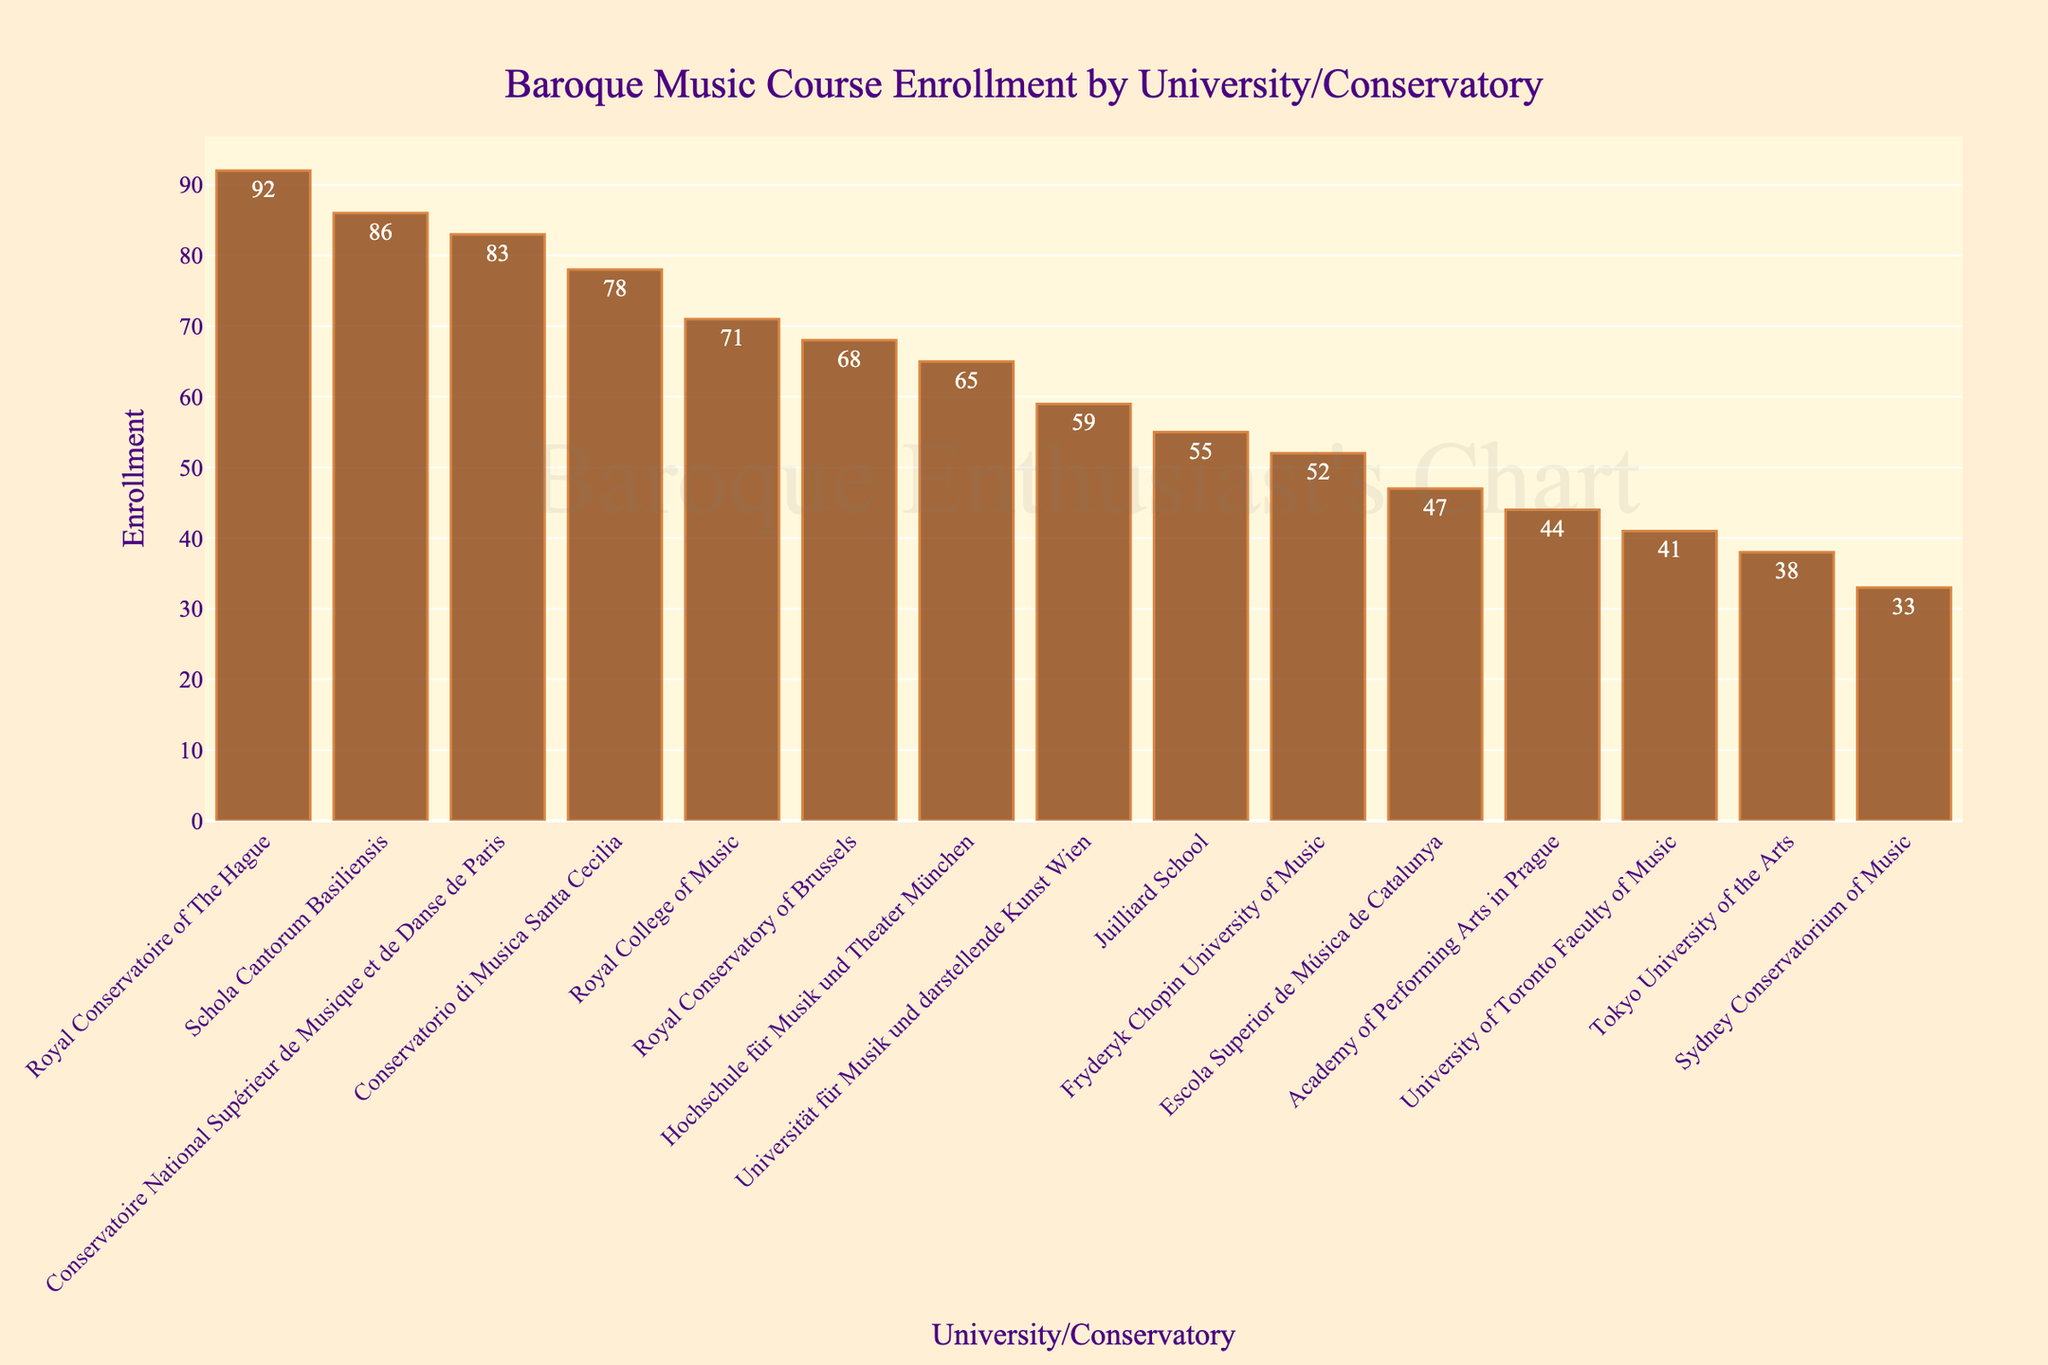Which university/conservatory has the highest enrollment in Baroque Music courses? Look for the tallest bar in the bar chart, which represents the university/conservatory with the highest enrollment. The Royal Conservatoire of The Hague has the highest enrollment.
Answer: Royal Conservatoire of The Hague Which country appears most frequently in the top 5 universities/conservatories for Baroque Music course enrollment? Identify the top 5 universities/conservatories based on bar height, then check the country associated with each. Netherland, France, Switzerland, Italy, and United Kingdom are the top 5, so no country appears more than once.
Answer: None How many more students are enrolled in Baroque Music courses at the Royal Conservatoire of The Hague compared to the Sydney Conservatorium of Music? Find the enrollment numbers for both institutions and subtract the smaller from the larger. The enrollment at the Royal Conservatoire of The Hague is 92 and at the Sydney Conservatorium of Music is 33. 92 - 33 = 59
Answer: 59 What is the combined enrollment for the universities/conservatories in Germany and France? Add the enrollment numbers for Hochschule für Musik und Theater München (Germany) and Conservatoire National Supérieur de Musique et de Danse de Paris (France). 65 + 83 = 148
Answer: 148 Which university/conservatory has the lowest enrollment in Baroque Music courses? Look for the shortest bar in the bar chart, which represents the university/conservatory with the lowest enrollment. The Sydney Conservatorium of Music has the lowest enrollment.
Answer: Sydney Conservatorium of Music Is the enrollment at Juilliard School higher or lower than the enrollment at Schola Cantorum Basiliensis? Compare the bar heights of Juilliard School and Schola Cantorum Basiliensis. The enrollment at Juilliard School is 55, and at Schola Cantorum Basiliensis it is 86. 55 is less than 86.
Answer: Lower What is the median enrollment value for all universities/conservatories listed? Sort all enrollment values in ascending order and find the middle value. The sorted enrollments are 33, 38, 41, 44, 47, 52, 55, 59, 65, 68, 71, 78, 83, 86, 92. The middle value (8th in the list) is 59.
Answer: 59 Which universities/conservatories have enrollments more than 70? Identify the bars taller than the 70 mark on the y-axis. Those with bars taller than 70 are Royal Conservatoire of The Hague (92), Conservatoire National Supérieur de Musique et de Danse de Paris (83), Schola Cantorum Basiliensis (86), Conservatorio di Musica Santa Cecilia (78), and Royal College of Music (71).
Answer: Royal Conservatoire of The Hague, Conservatoire National Supérieur de Musique et de Danse de Paris, Schola Cantorum Basiliensis, Conservatorio di Musica Santa Cecilia, Royal College of Music 